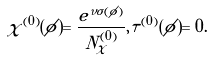Convert formula to latex. <formula><loc_0><loc_0><loc_500><loc_500>\chi ^ { ( 0 ) } ( \phi ) = \frac { e ^ { \nu \sigma ( \phi ) } } { N ^ { ( 0 ) } _ { \chi } } , \tau ^ { ( 0 ) } ( \phi ) = 0 .</formula> 